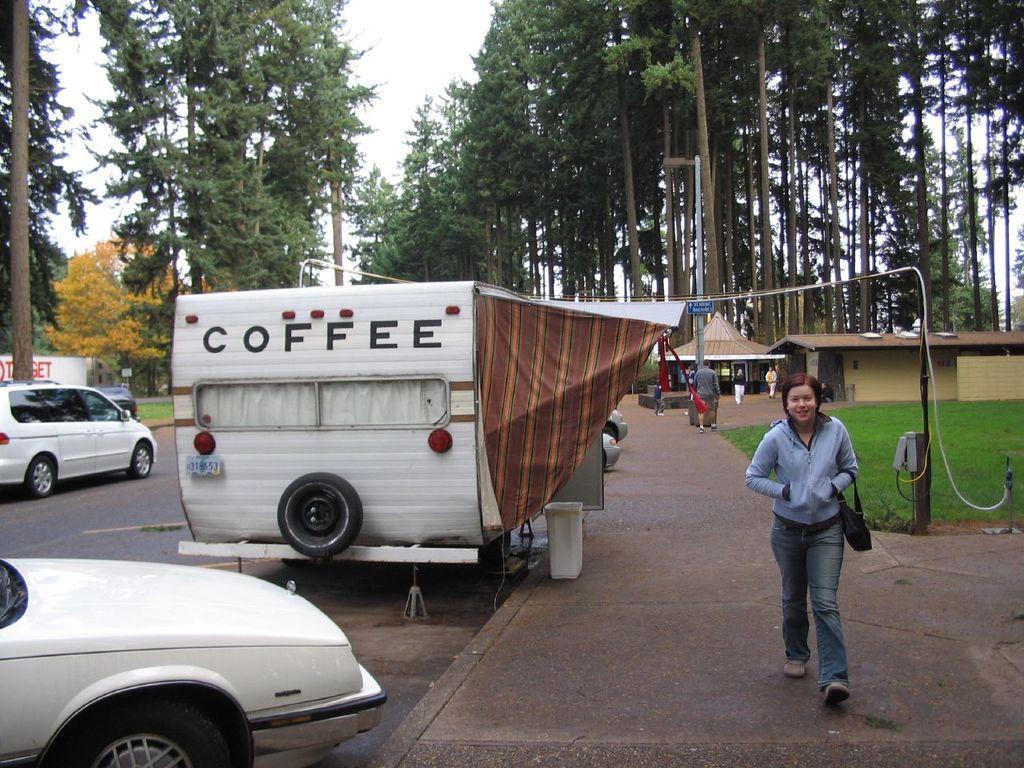How would you summarize this image in a sentence or two? This picture is clicked outside the city. The woman in front of the picture wearing a blue jacket and a black bag is walking on the road. Beside her, we see two vehicles are parked on the road. On the left side, we see a white car is moving on the road. Behind her, we see a pole and grass. We see people walking on the road. There are trees and a building in the background. 